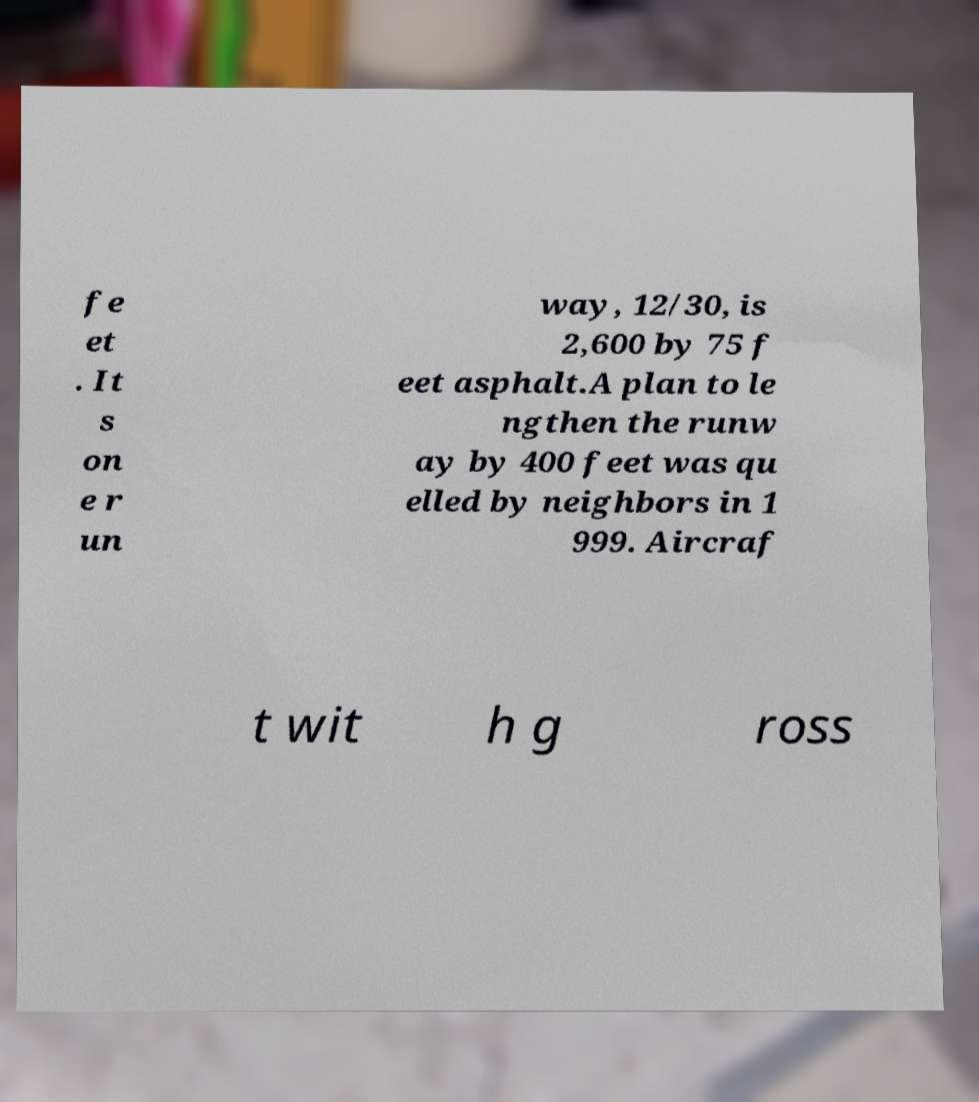Could you assist in decoding the text presented in this image and type it out clearly? fe et . It s on e r un way, 12/30, is 2,600 by 75 f eet asphalt.A plan to le ngthen the runw ay by 400 feet was qu elled by neighbors in 1 999. Aircraf t wit h g ross 